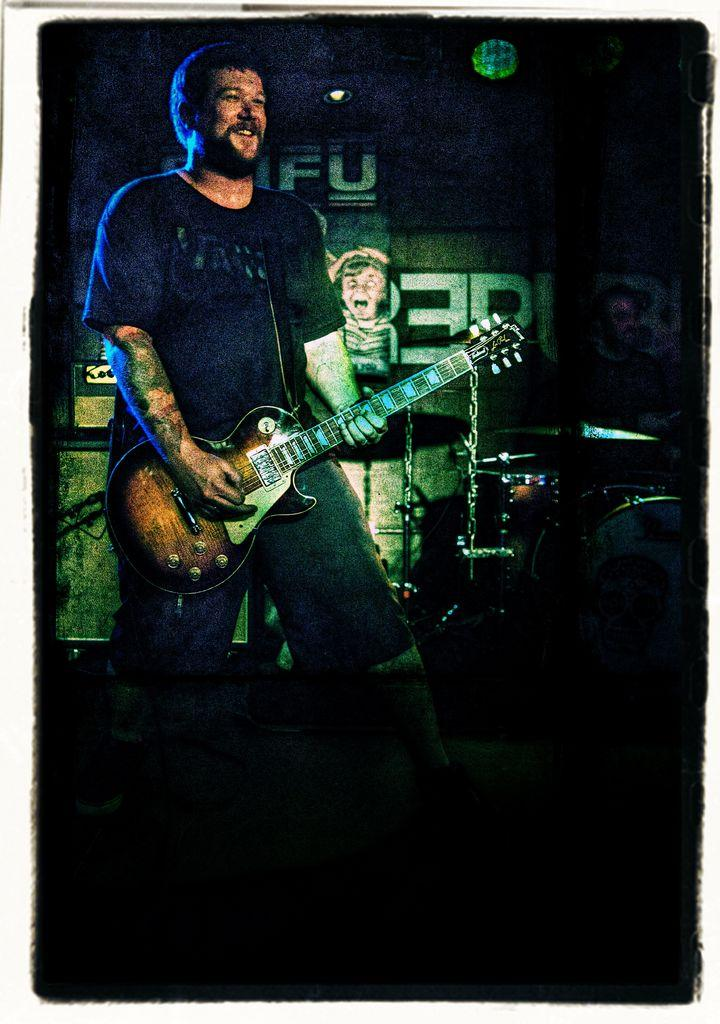What is the main subject of the image? There is a man standing in the center of the image. What is the man holding in the image? The man is holding a guitar. What can be seen in the background of the image? There is a wall and musical instruments in the background of the image. How many children are playing with fish in the image? There are no children or fish present in the image. What type of eggs can be seen in the image? There are no eggs visible in the image. 